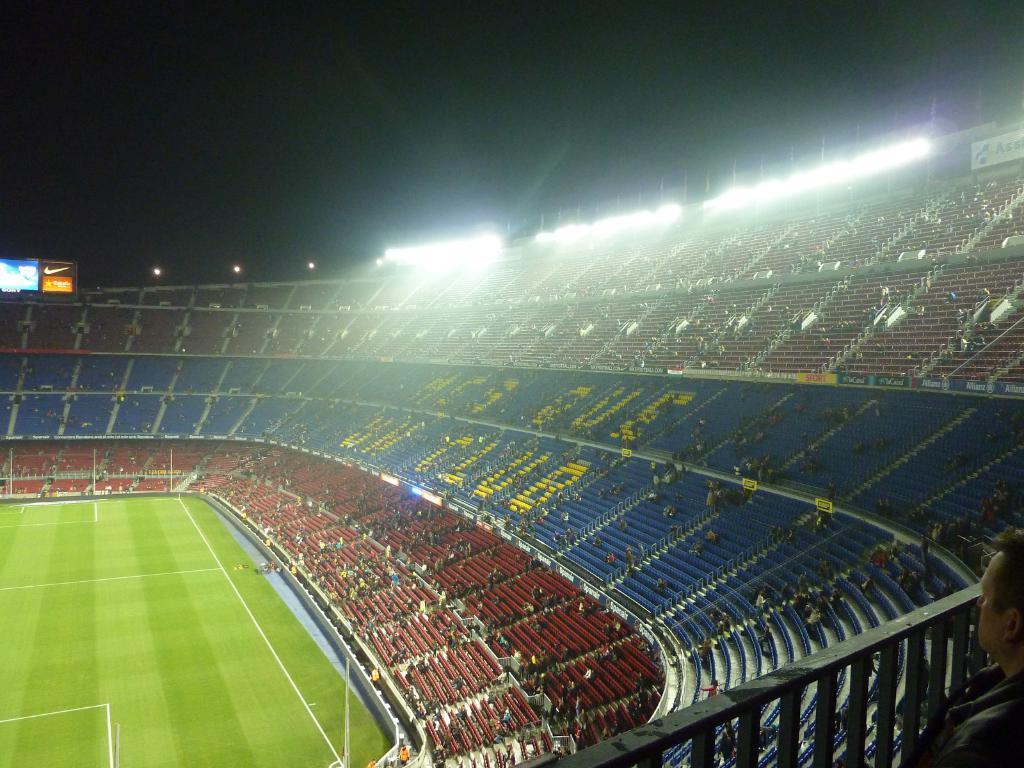In one or two sentences, can you explain what this image depicts? In this image I can see a stadium. There are chairs, stairs, name boards, group of people, lights and there is ground. Also there is a dark background. 